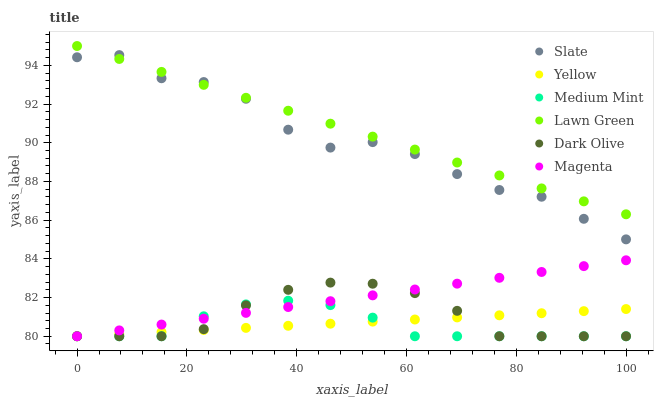Does Medium Mint have the minimum area under the curve?
Answer yes or no. Yes. Does Lawn Green have the maximum area under the curve?
Answer yes or no. Yes. Does Slate have the minimum area under the curve?
Answer yes or no. No. Does Slate have the maximum area under the curve?
Answer yes or no. No. Is Lawn Green the smoothest?
Answer yes or no. Yes. Is Slate the roughest?
Answer yes or no. Yes. Is Slate the smoothest?
Answer yes or no. No. Is Lawn Green the roughest?
Answer yes or no. No. Does Medium Mint have the lowest value?
Answer yes or no. Yes. Does Slate have the lowest value?
Answer yes or no. No. Does Lawn Green have the highest value?
Answer yes or no. Yes. Does Slate have the highest value?
Answer yes or no. No. Is Yellow less than Lawn Green?
Answer yes or no. Yes. Is Lawn Green greater than Yellow?
Answer yes or no. Yes. Does Slate intersect Lawn Green?
Answer yes or no. Yes. Is Slate less than Lawn Green?
Answer yes or no. No. Is Slate greater than Lawn Green?
Answer yes or no. No. Does Yellow intersect Lawn Green?
Answer yes or no. No. 